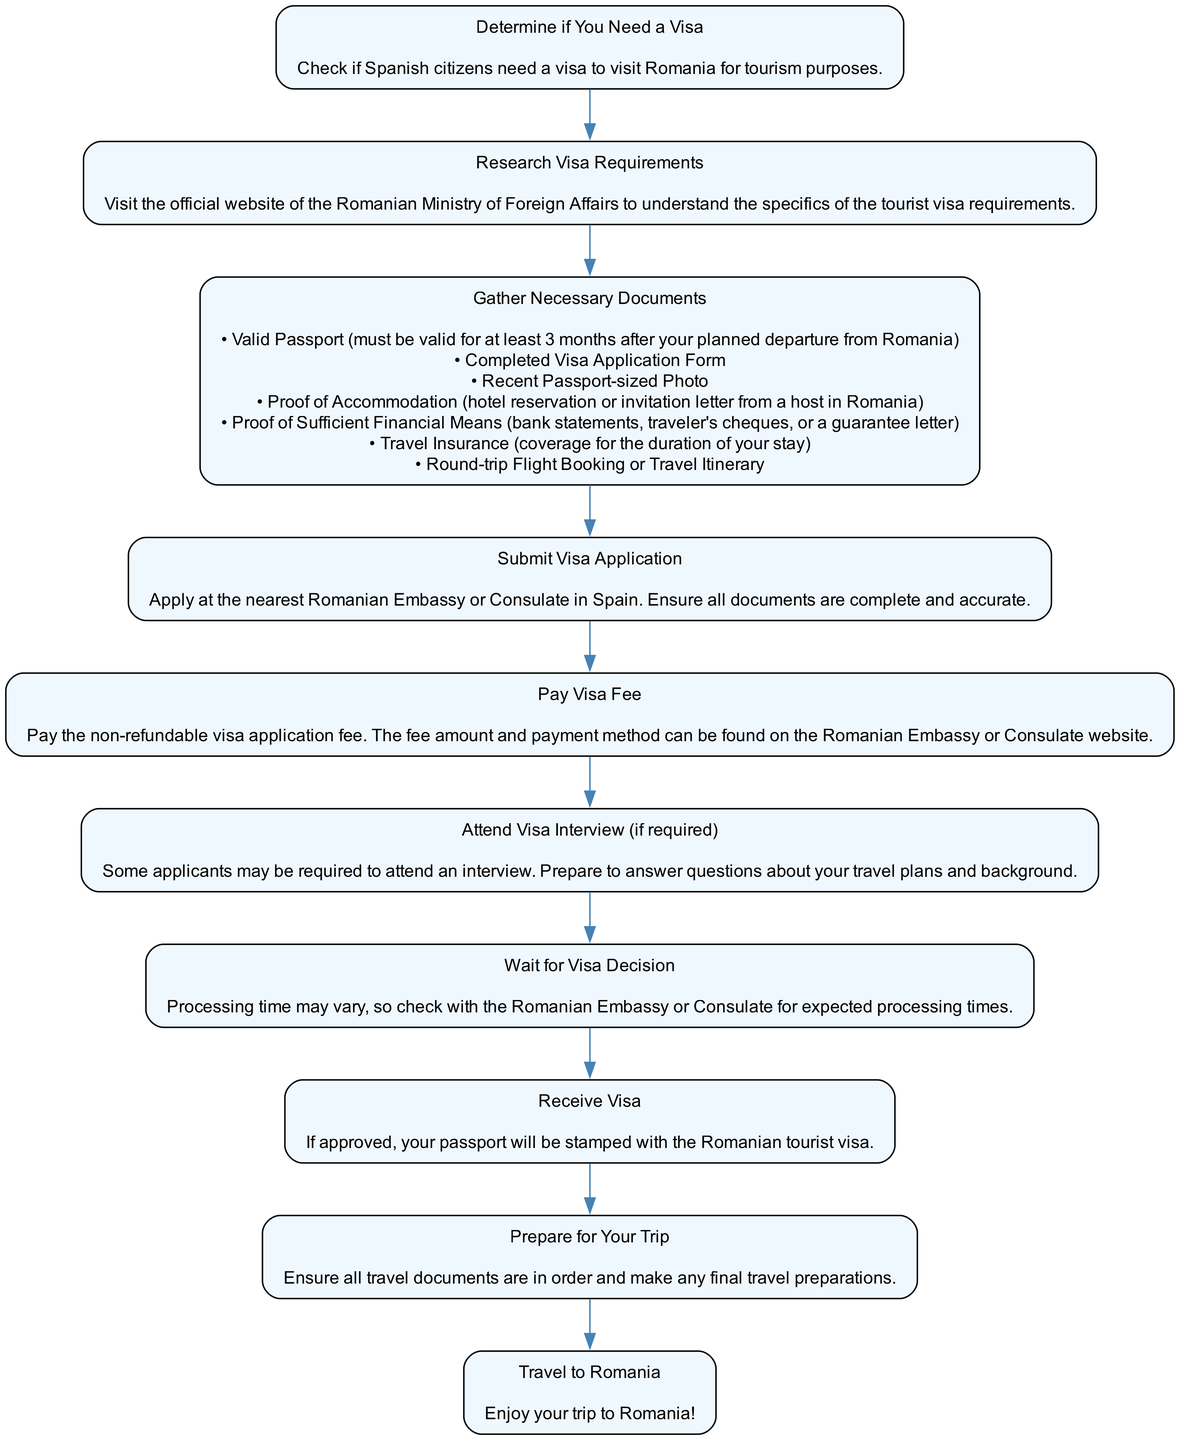What is the first step in the process? The first step in the flow chart is "Determine if You Need a Visa", which directs Spanish citizens to check the visa requirements for Romania.
Answer: Determine if You Need a Visa How many documents need to be gathered? The "Gather Necessary Documents" node lists seven specific documents that must be collected by the applicant.
Answer: 7 What do you do after submitting your application? Following the "Submit Visa Application" step, the next action in the flow is to "Pay Visa Fee".
Answer: Pay Visa Fee What is required if an interview is needed? If an interview is required, applicants must "Attend Visa Interview (if required)", preparing to answer questions about their travel plans and background.
Answer: Attend Visa Interview (if required) What is the last step of the process? The last step in the flow chart is "Travel to Romania", which indicates the culmination of the entire process leading to the actual trip.
Answer: Travel to Romania What comes after paying the visa fee? After paying the visa fee, the next step in the sequence is to "Wait for Visa Decision", indicating that applicants must wait for the outcome of their visa application.
Answer: Wait for Visa Decision What must you prepare before traveling? Before the actual trip, the flow chart directs you to "Prepare for Your Trip", ensuring that all travel documents are in order and final preparations are made.
Answer: Prepare for Your Trip 